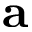Convert formula to latex. <formula><loc_0><loc_0><loc_500><loc_500>a</formula> 